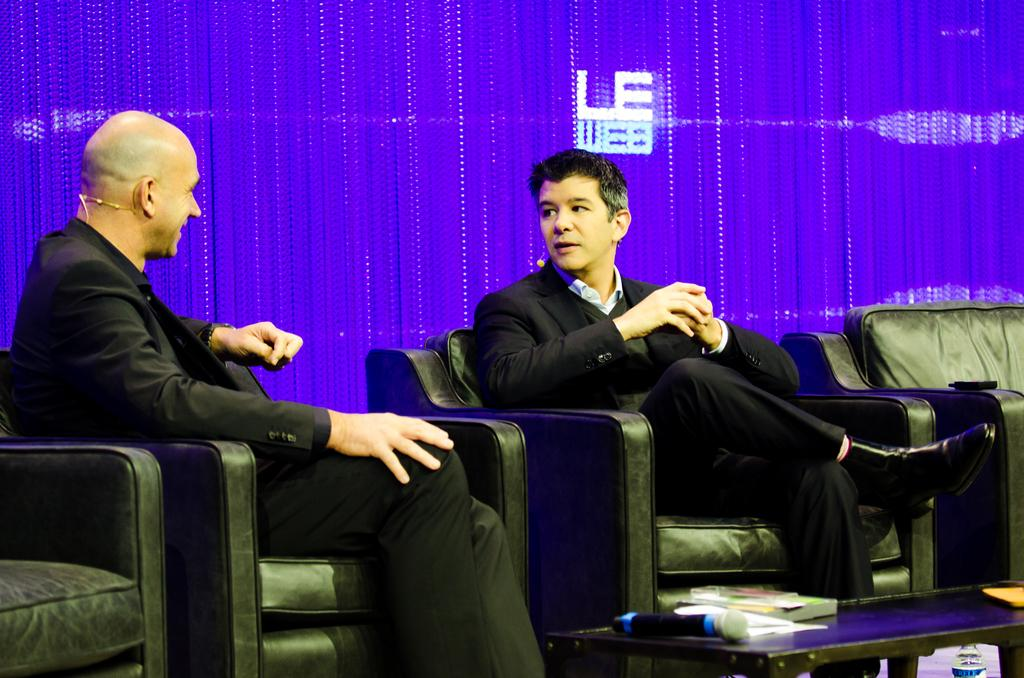How many people are sitting in the image? There are two men sitting in the image. What is present in the image besides the men? There is a table in the image. What can be seen on the table? There is a mic on the table. Is there anything else under the mic on the table? Yes, there is a bottle under the mic on the table. Are there any slaves present in the image? No, there are no slaves present in the image. What type of hall can be seen in the background of the image? There is no hall visible in the image; it only shows two men sitting at a table with a mic and a bottle. 